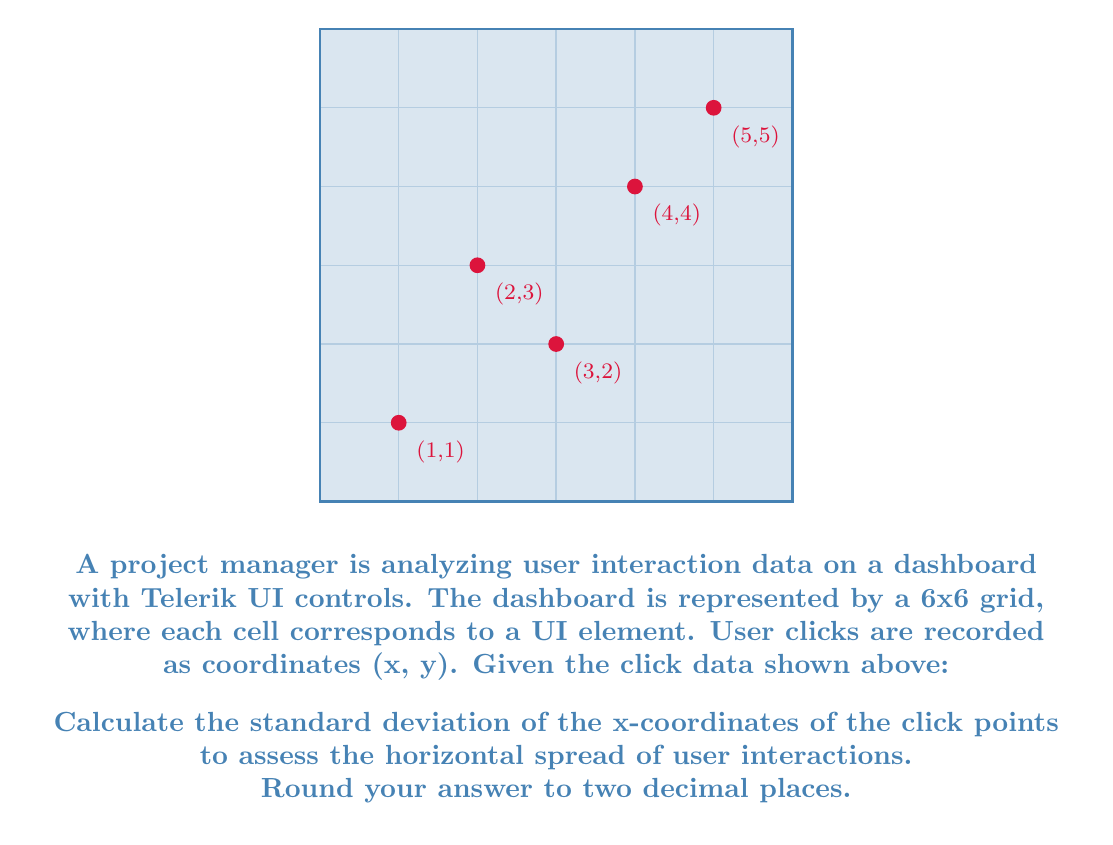Help me with this question. To calculate the standard deviation of the x-coordinates, we'll follow these steps:

1. List the x-coordinates: 1, 2, 3, 4, 5

2. Calculate the mean (μ) of the x-coordinates:
   $$ \mu = \frac{1 + 2 + 3 + 4 + 5}{5} = 3 $$

3. Calculate the squared differences from the mean:
   $$ (1-3)^2 = 4 $$
   $$ (2-3)^2 = 1 $$
   $$ (3-3)^2 = 0 $$
   $$ (4-3)^2 = 1 $$
   $$ (5-3)^2 = 4 $$

4. Calculate the average of the squared differences (variance):
   $$ \text{Variance} = \frac{4 + 1 + 0 + 1 + 4}{5} = 2 $$

5. Take the square root of the variance to get the standard deviation:
   $$ \text{Standard Deviation} = \sqrt{2} \approx 1.4142 $$

6. Round to two decimal places: 1.41

This standard deviation indicates the average distance of x-coordinates from the mean, providing insight into the horizontal spread of user interactions on the dashboard.
Answer: 1.41 